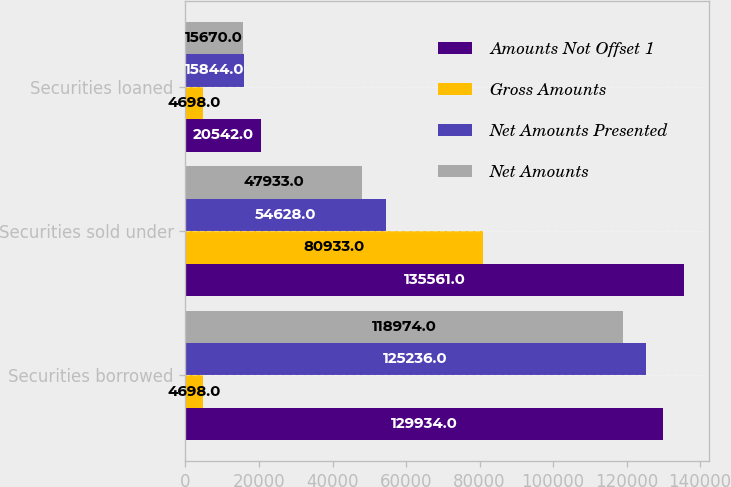Convert chart to OTSL. <chart><loc_0><loc_0><loc_500><loc_500><stacked_bar_chart><ecel><fcel>Securities borrowed<fcel>Securities sold under<fcel>Securities loaned<nl><fcel>Amounts Not Offset 1<fcel>129934<fcel>135561<fcel>20542<nl><fcel>Gross Amounts<fcel>4698<fcel>80933<fcel>4698<nl><fcel>Net Amounts Presented<fcel>125236<fcel>54628<fcel>15844<nl><fcel>Net Amounts<fcel>118974<fcel>47933<fcel>15670<nl></chart> 